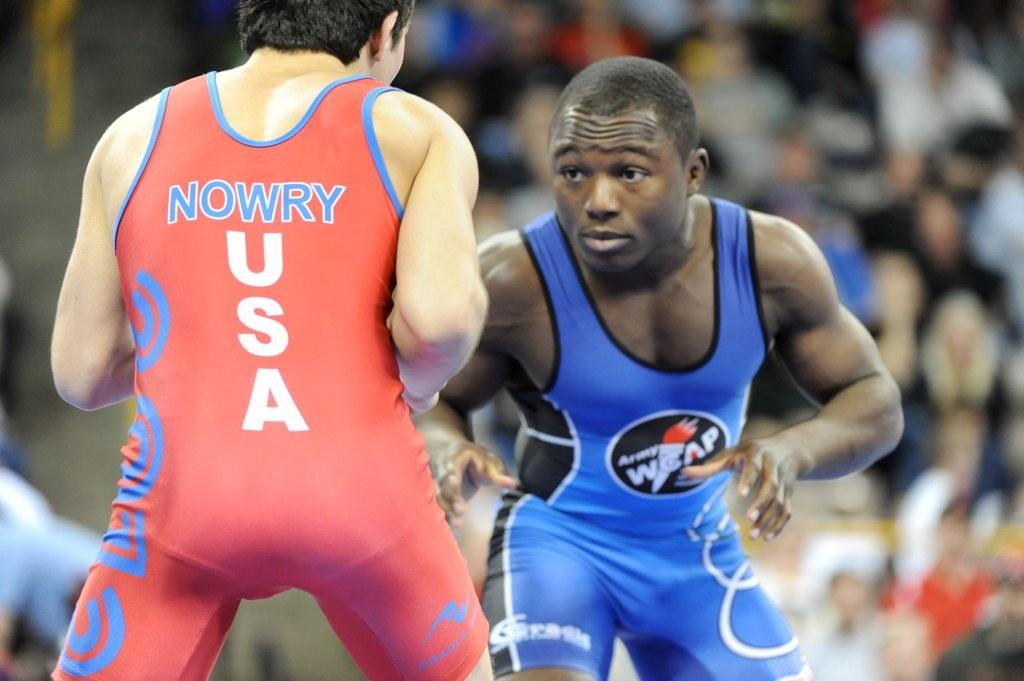<image>
Give a short and clear explanation of the subsequent image. A wrestler with the word Nowry on the back is facing off against an opponent. 